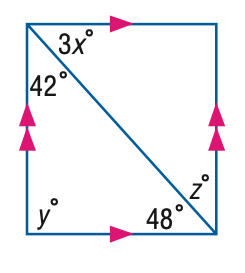Answer the mathemtical geometry problem and directly provide the correct option letter.
Question: Find y in the figure.
Choices: A: 42 B: 48 C: 80 D: 90 D 